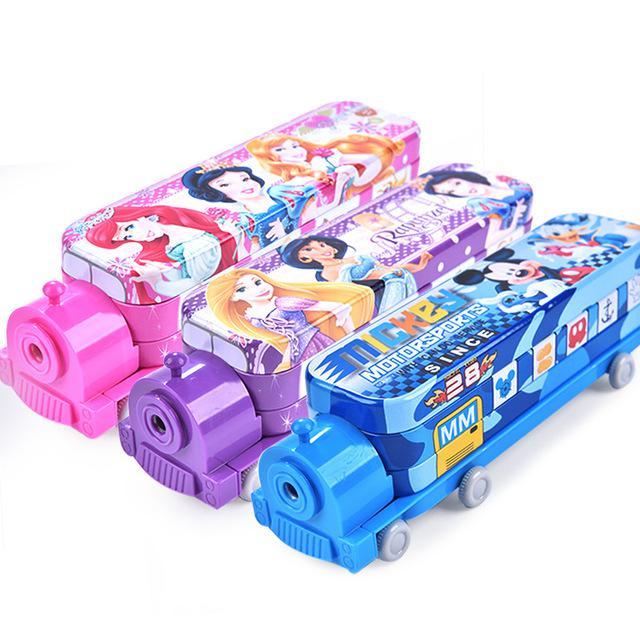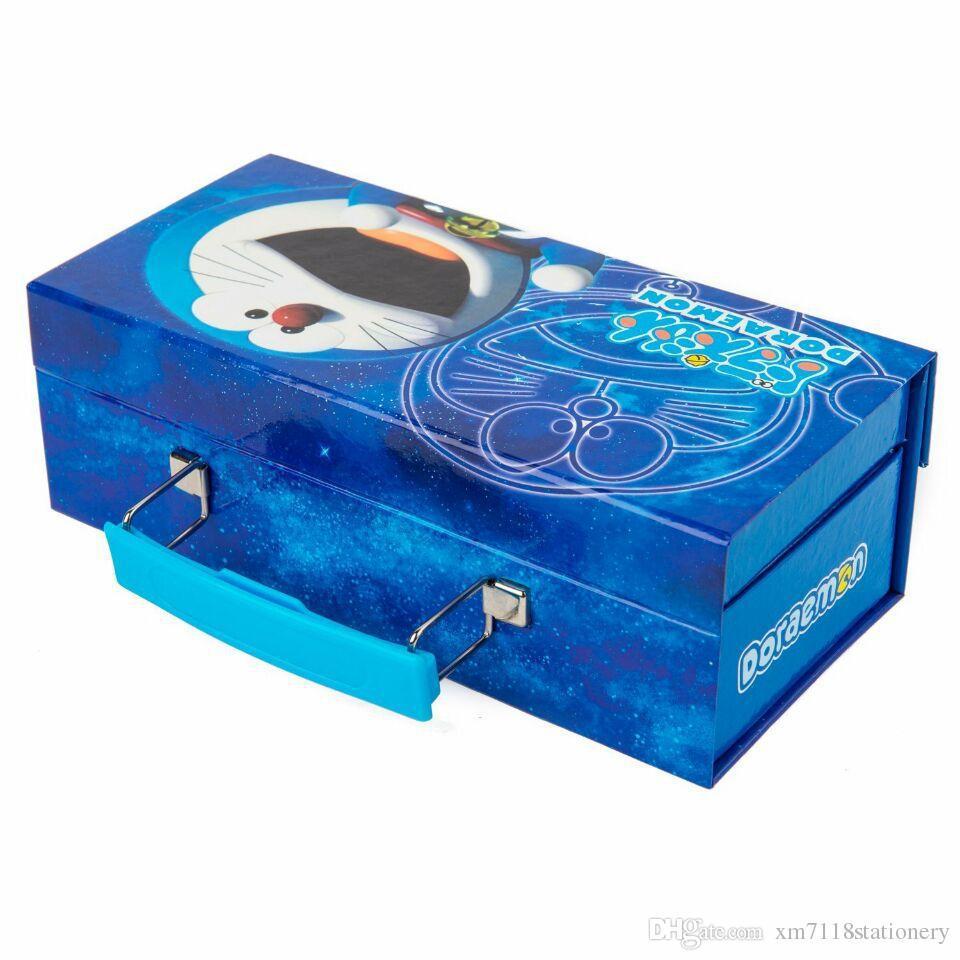The first image is the image on the left, the second image is the image on the right. Analyze the images presented: Is the assertion "There is at least one pen inside an open 3 layered pencil case." valid? Answer yes or no. No. The first image is the image on the left, the second image is the image on the right. Considering the images on both sides, is "An image shows three variations of the same kind of case, each a different color." valid? Answer yes or no. Yes. 